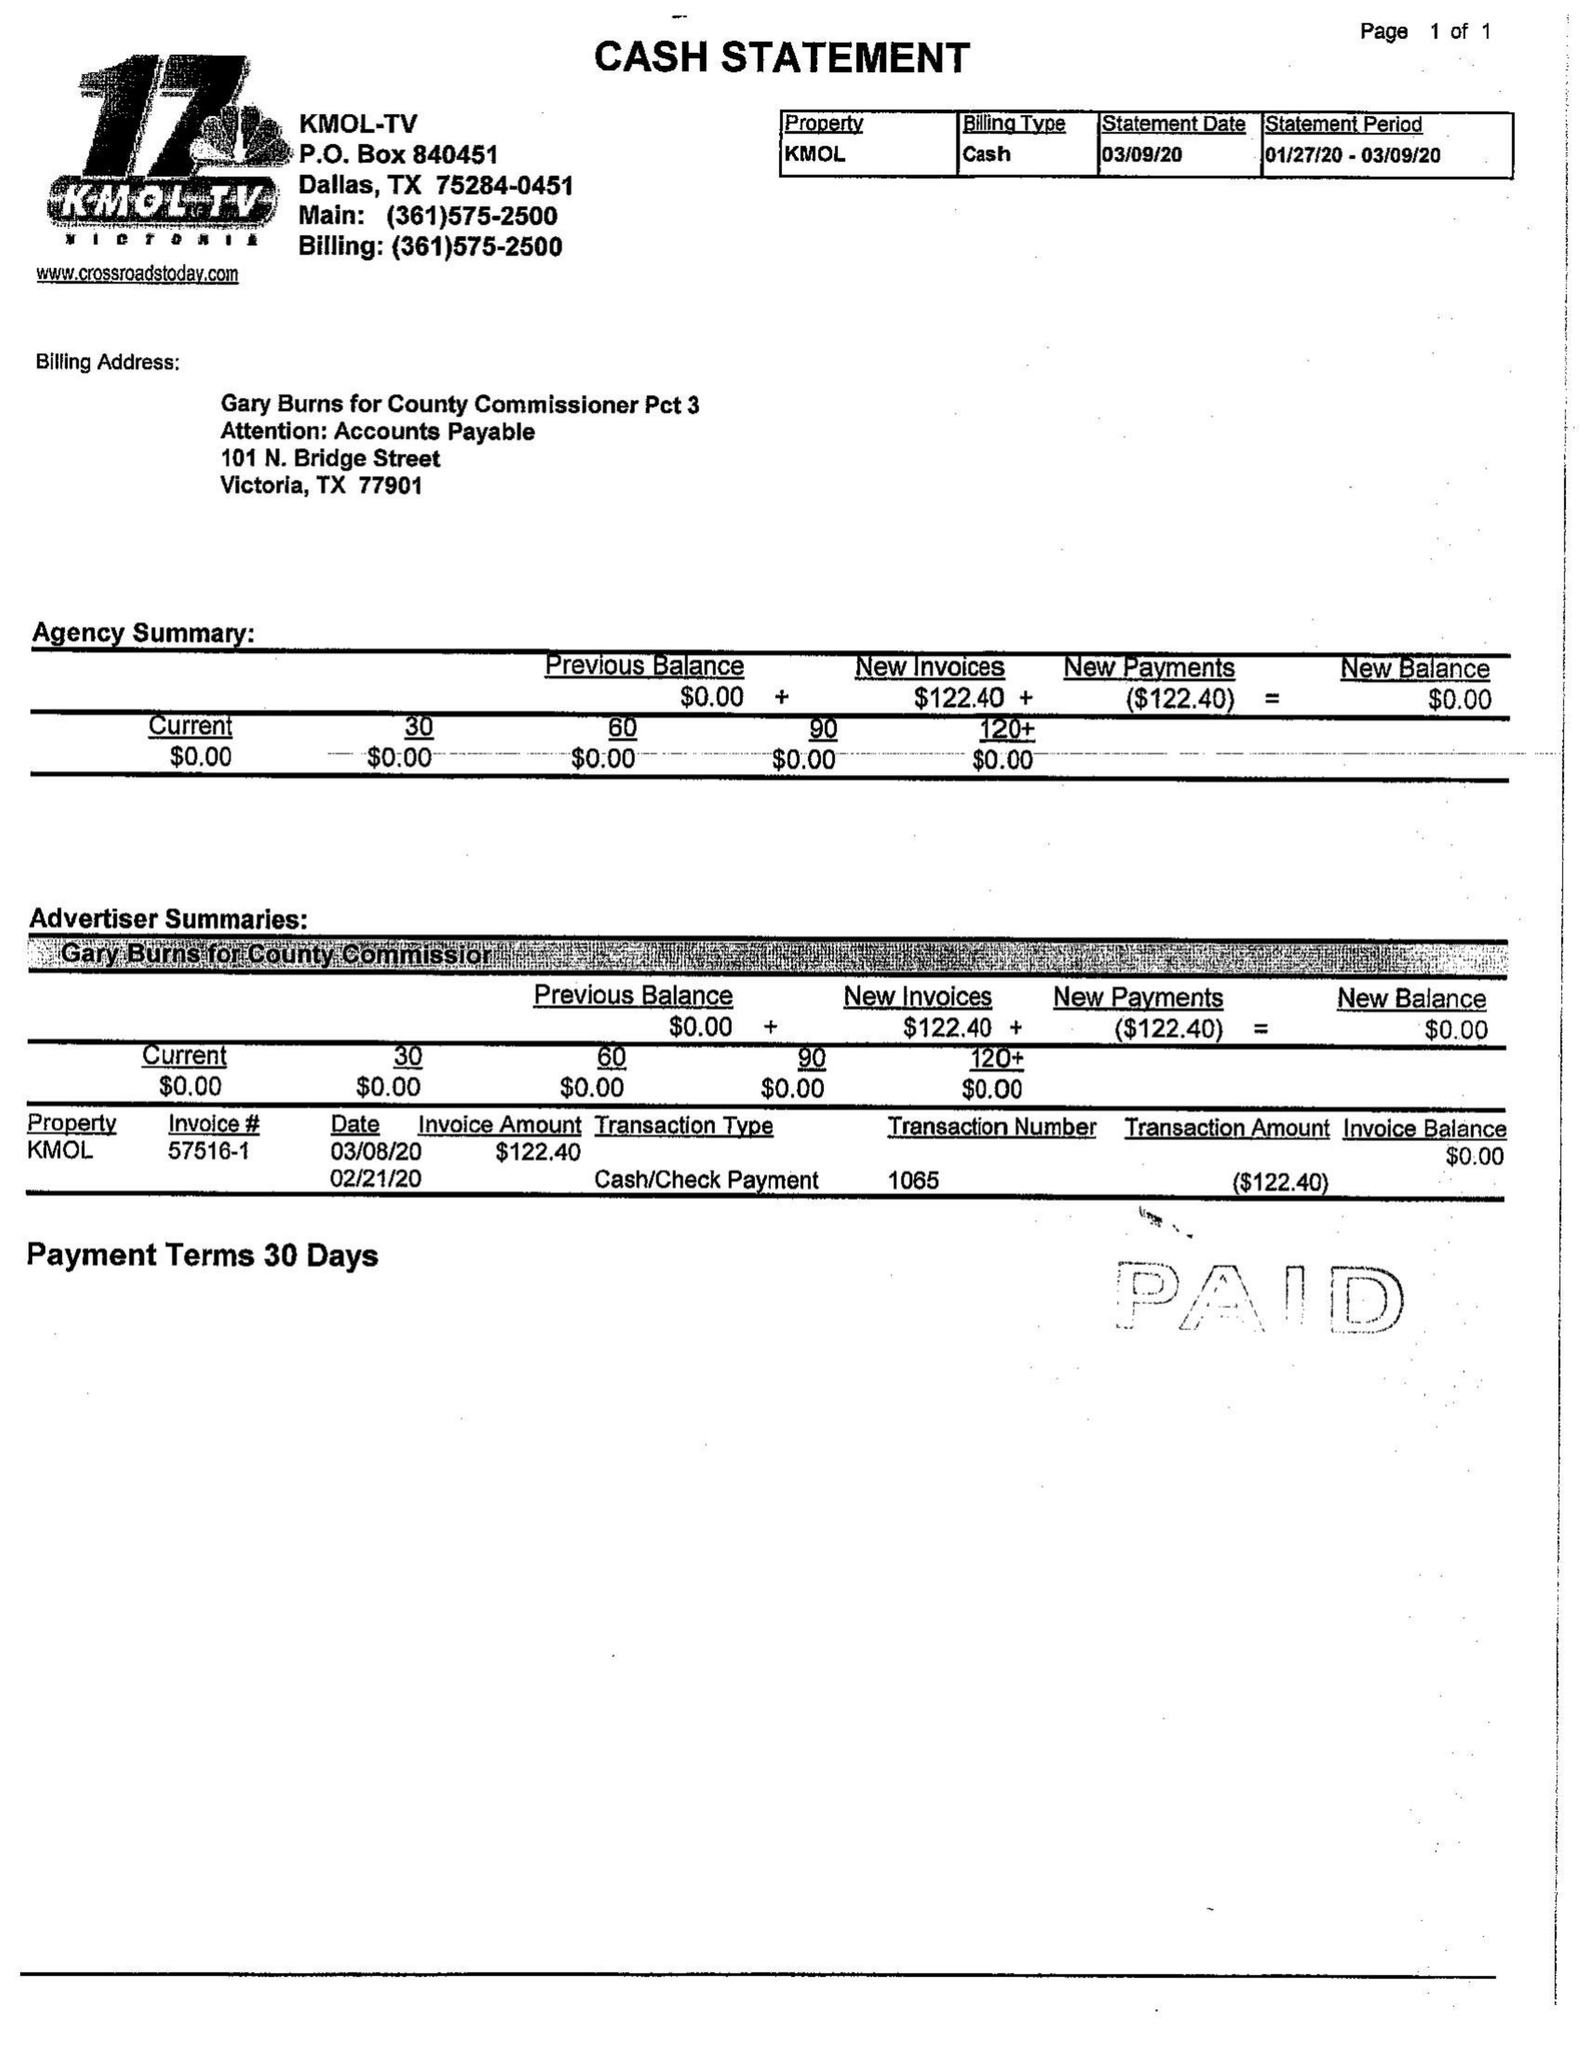What is the value for the gross_amount?
Answer the question using a single word or phrase. 144.00 